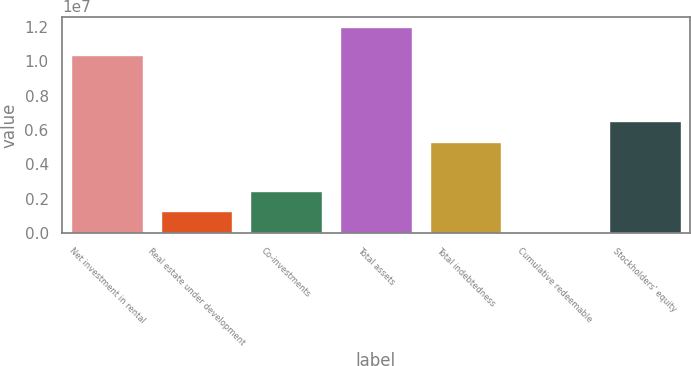<chart> <loc_0><loc_0><loc_500><loc_500><bar_chart><fcel>Net investment in rental<fcel>Real estate under development<fcel>Co-investments<fcel>Total assets<fcel>Total indebtedness<fcel>Cumulative redeemable<fcel>Stockholders' equity<nl><fcel>1.03816e+07<fcel>1.26688e+06<fcel>2.46002e+06<fcel>1.20051e+07<fcel>5.31546e+06<fcel>73750<fcel>6.5086e+06<nl></chart> 